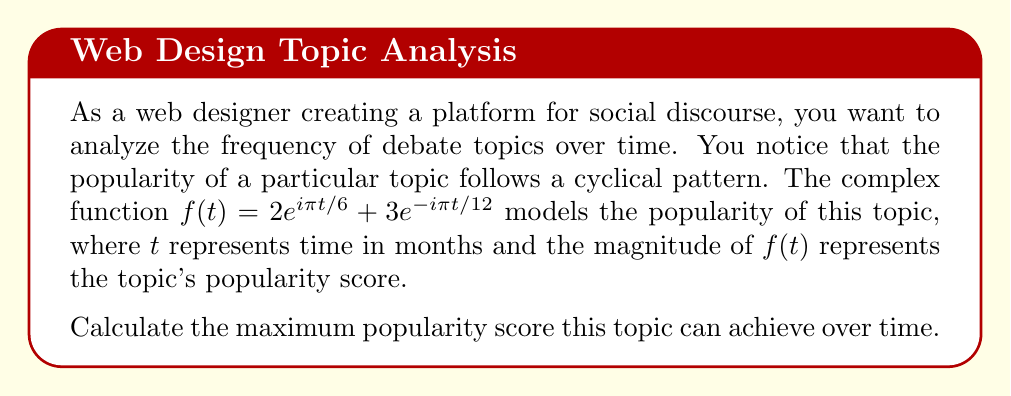Can you answer this question? To find the maximum popularity score, we need to determine the maximum magnitude of the complex function $f(t)$. Let's approach this step-by-step:

1) First, we can represent the function in the form $a = x + yi$:

   $f(t) = 2(\cos(\pi t/6) + i\sin(\pi t/6)) + 3(\cos(-\pi t/12) + i\sin(-\pi t/12))$

2) Expand this:

   $f(t) = 2\cos(\pi t/6) + 2i\sin(\pi t/6) + 3\cos(\pi t/12) - 3i\sin(\pi t/12)$

3) Group real and imaginary parts:

   $f(t) = (2\cos(\pi t/6) + 3\cos(\pi t/12)) + i(2\sin(\pi t/6) - 3\sin(\pi t/12))$

4) The magnitude of a complex number $a + bi$ is given by $\sqrt{a^2 + b^2}$. So, the magnitude of $f(t)$ is:

   $|f(t)| = \sqrt{(2\cos(\pi t/6) + 3\cos(\pi t/12))^2 + (2\sin(\pi t/6) - 3\sin(\pi t/12))^2}$

5) Expand this:

   $|f(t)| = \sqrt{4\cos^2(\pi t/6) + 12\cos(\pi t/6)\cos(\pi t/12) + 9\cos^2(\pi t/12) + 4\sin^2(\pi t/6) + 12\sin(\pi t/6)\sin(\pi t/12) + 9\sin^2(\pi t/12)}$

6) Simplify using trigonometric identities $\cos^2(x) + \sin^2(x) = 1$:

   $|f(t)| = \sqrt{4 + 9 + 12(\cos(\pi t/6)\cos(\pi t/12) + \sin(\pi t/6)\sin(\pi t/12))}$

7) Use the cosine of difference formula $\cos(A-B) = \cos A \cos B + \sin A \sin B$:

   $|f(t)| = \sqrt{13 + 12\cos(\pi t/6 - \pi t/12)} = \sqrt{13 + 12\cos(\pi t/12)}$

8) The maximum value of cosine is 1, so the maximum value of this expression occurs when $\cos(\pi t/12) = 1$:

   $\max|f(t)| = \sqrt{13 + 12} = \sqrt{25} = 5$

Therefore, the maximum popularity score the topic can achieve is 5.
Answer: The maximum popularity score the topic can achieve is 5. 